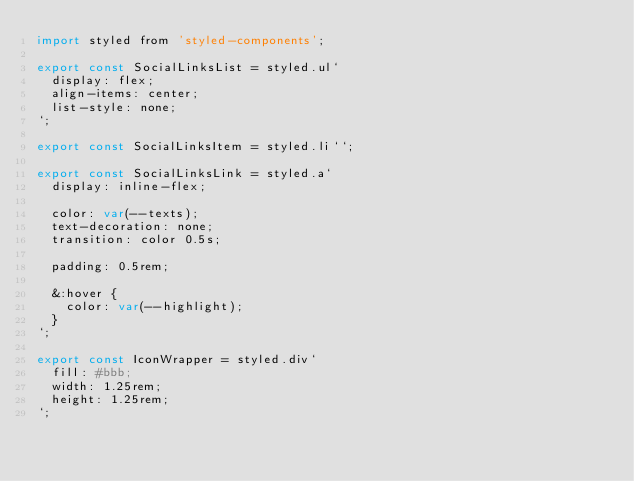<code> <loc_0><loc_0><loc_500><loc_500><_JavaScript_>import styled from 'styled-components';

export const SocialLinksList = styled.ul`
  display: flex;
  align-items: center;
  list-style: none;
`;

export const SocialLinksItem = styled.li``;

export const SocialLinksLink = styled.a`
  display: inline-flex;

  color: var(--texts);
  text-decoration: none;
  transition: color 0.5s;

  padding: 0.5rem;

  &:hover {
    color: var(--highlight);
  }
`;

export const IconWrapper = styled.div`
  fill: #bbb;
  width: 1.25rem;
  height: 1.25rem;
`;
</code> 